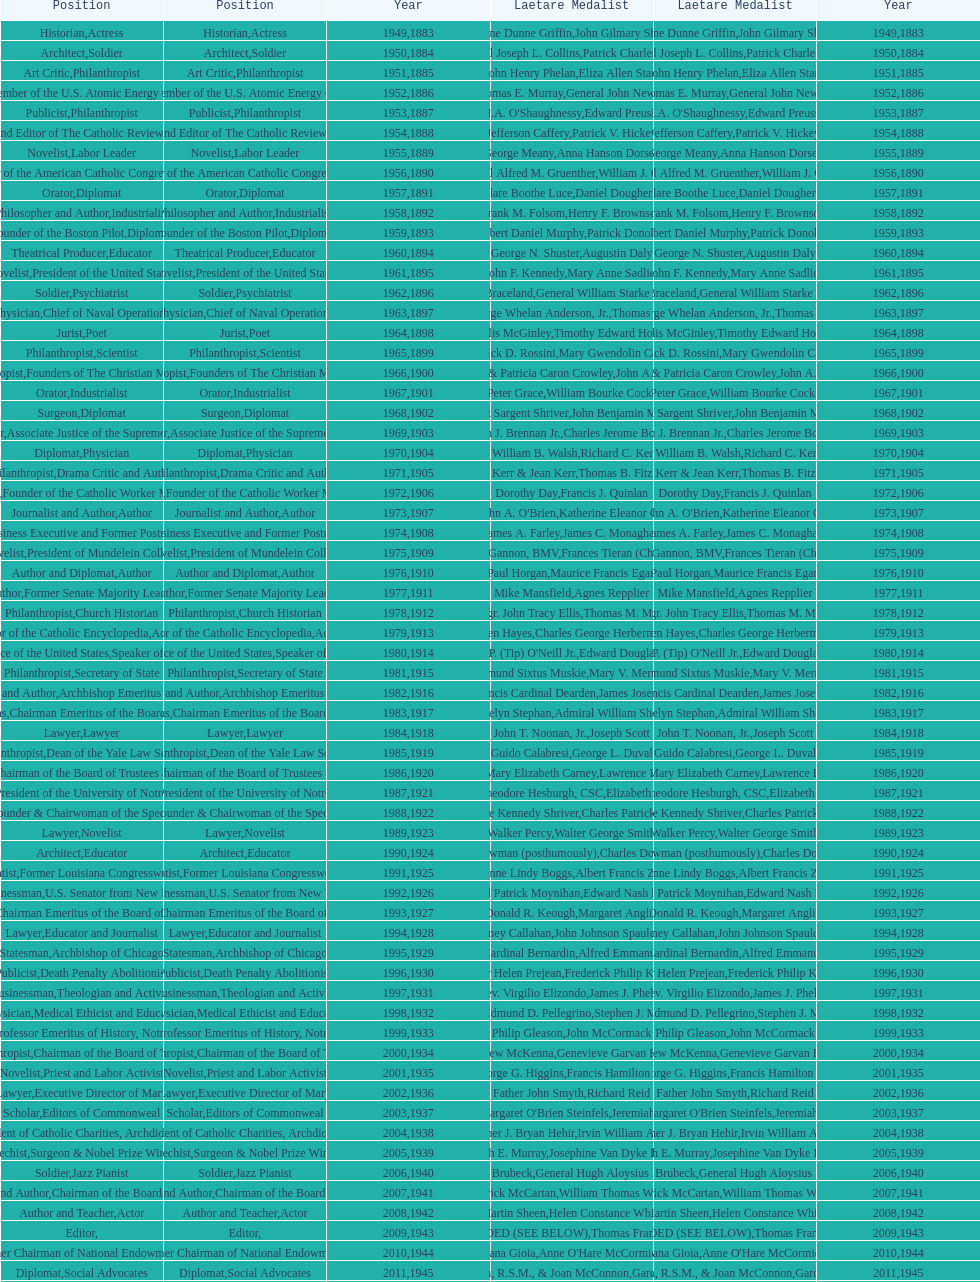What are the total number of times soldier is listed as the position on this chart? 4. 